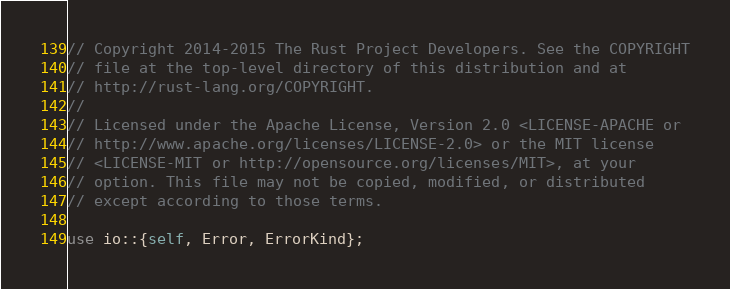<code> <loc_0><loc_0><loc_500><loc_500><_Rust_>// Copyright 2014-2015 The Rust Project Developers. See the COPYRIGHT
// file at the top-level directory of this distribution and at
// http://rust-lang.org/COPYRIGHT.
//
// Licensed under the Apache License, Version 2.0 <LICENSE-APACHE or
// http://www.apache.org/licenses/LICENSE-2.0> or the MIT license
// <LICENSE-MIT or http://opensource.org/licenses/MIT>, at your
// option. This file may not be copied, modified, or distributed
// except according to those terms.

use io::{self, Error, ErrorKind};</code> 